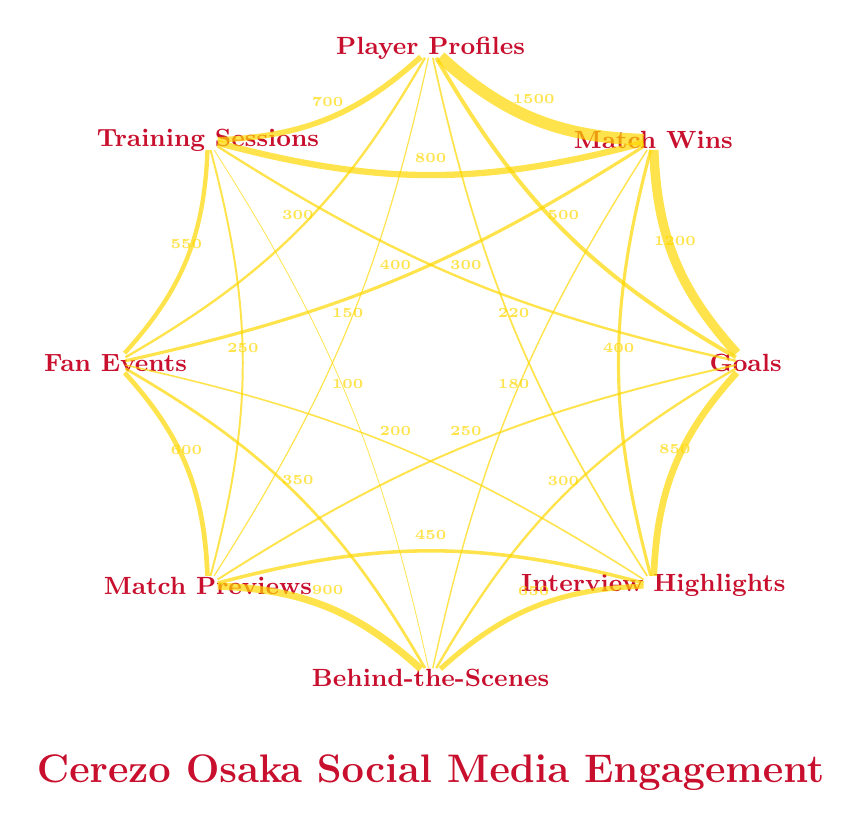What is the total number of likes for Match Wins? The diagram indicates that the connections related to Match Wins show a value of 1500 for likes. Therefore, we can conclude that the total likes for Match Wins is 1500.
Answer: 1500 Which type of post received the most shares? By looking at the connections in the diagram, the type of post with the highest number of shares is Match Wins, with a value of 800.
Answer: Match Wins How many likes were generated by Player Profiles? The diagram shows that Player Profiles received 700 likes, so this is the answer we can derive directly from the connections.
Answer: 700 What is the total number of comments related to Goals? From the diagram, the connection from Goals to Comments has a value of 300. This indicates there were 300 comments related to Goals.
Answer: 300 Which type of post has a higher engagement, Training Sessions or Fan Events? We need to compare the total engagements of both. Training Sessions have likes of 550, shares of 250, and comments of 100, totaling 900. Fan Events have likes of 600, shares of 350, and comments of 200, totaling 1150. Thus, Fan Events has a higher engagement.
Answer: Fan Events How many comments did Interview Highlights receive? The diagram specifically lists the comments for Interview Highlights, which is shown to be 220. Therefore, the answer is straightforward.
Answer: 220 What is the relationship between Behind-the-Scenes and Comments? The connection from Behind-the-Scenes to Comments shows a value of 180, indicating that there were 180 comments related to Behind-the-Scenes posts.
Answer: 180 Which type of post generated the least likes? Reviewing the connections, Training Sessions generated the least likes with a total of 550, which is lower than any other type of post listed in the diagram.
Answer: Training Sessions Which two types of posts have the same number of comments? By analyzing the values, both Player Profiles and Training Sessions have the same number for comments (150 and 100 respectively), but Player Profiles have a higher quantity than Training Sessions, so this does not fit the question criteria. Hence, the focus will be on Training Sessions with 100 comments and Behind-the-Scenes with 180, where the lowest two in play are relevant.
Answer: Training Sessions and Behind-the-Scenes 